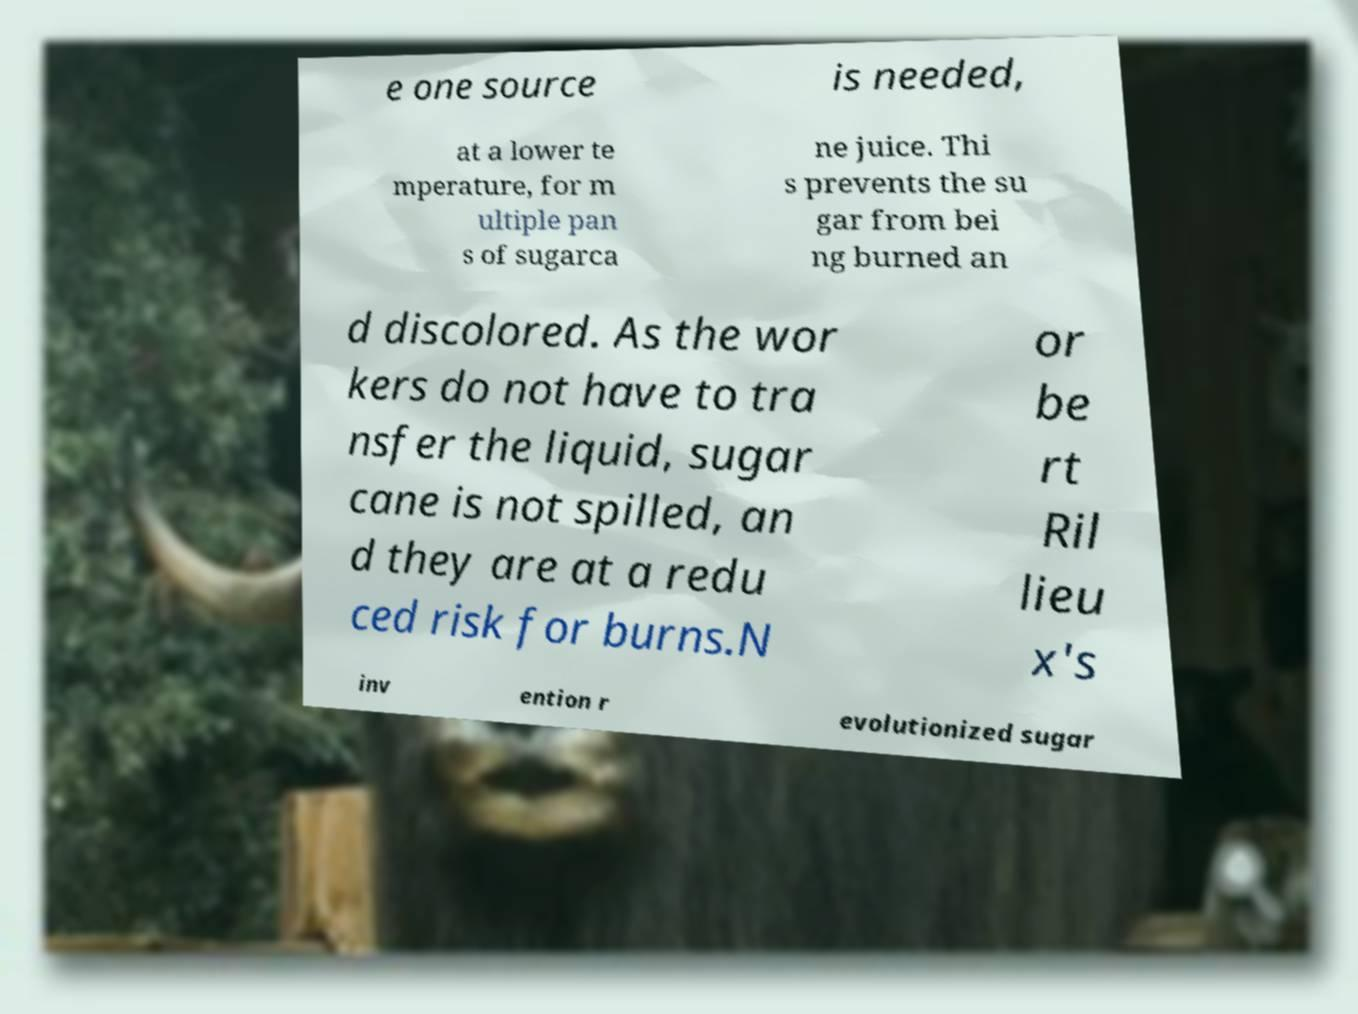What messages or text are displayed in this image? I need them in a readable, typed format. e one source is needed, at a lower te mperature, for m ultiple pan s of sugarca ne juice. Thi s prevents the su gar from bei ng burned an d discolored. As the wor kers do not have to tra nsfer the liquid, sugar cane is not spilled, an d they are at a redu ced risk for burns.N or be rt Ril lieu x's inv ention r evolutionized sugar 